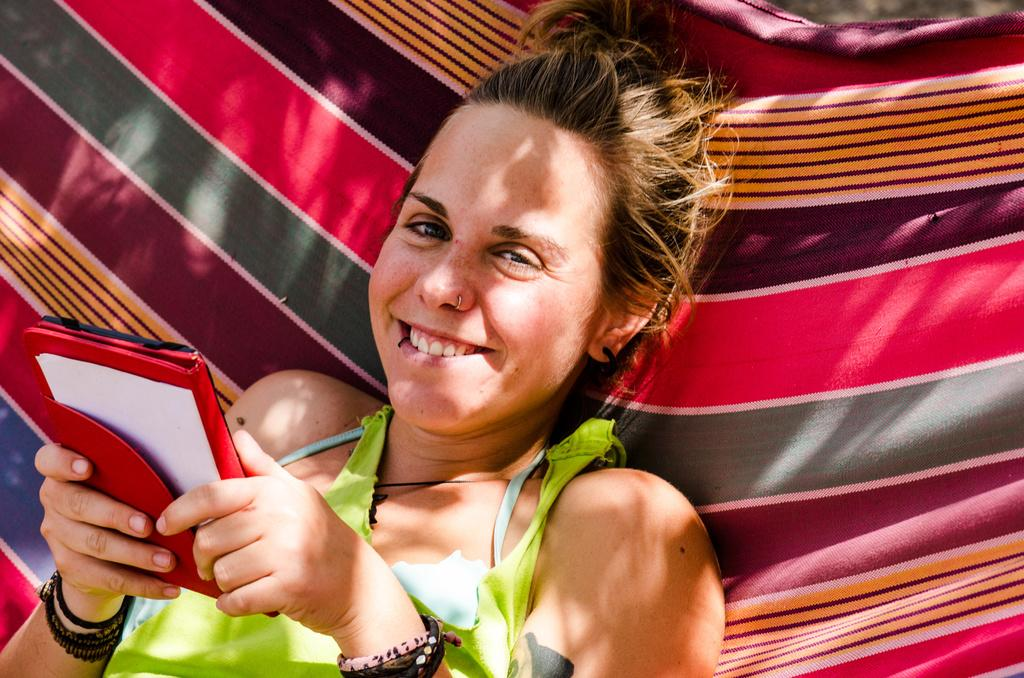Who is the main subject in the image? There is a woman in the image. What is the woman doing in the image? The woman is lying down and smiling. What is the woman holding in the image? The woman is holding an object. What is the woman wearing in the image? The woman is wearing a green dress. What type of linen is the woman using to learn in the image? There is no linen or learning activity present in the image. The woman is simply lying down and smiling while holding an object. 